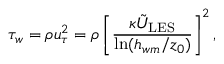Convert formula to latex. <formula><loc_0><loc_0><loc_500><loc_500>\tau _ { w } = \rho u _ { \tau } ^ { 2 } = \rho \left [ \frac { \kappa \tilde { U } _ { L E S } } { \ln ( h _ { w m } / z _ { 0 } ) } \right ] ^ { 2 } ,</formula> 